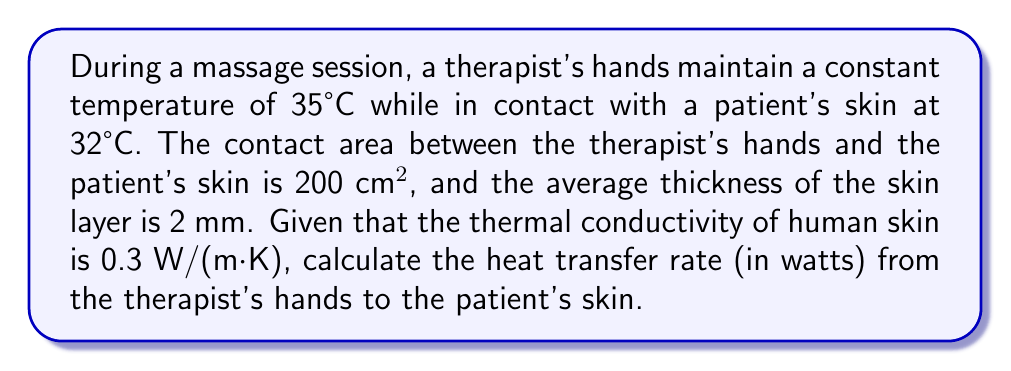Could you help me with this problem? To solve this problem, we'll use Fourier's law of heat conduction:

$$ Q = -kA\frac{dT}{dx} $$

Where:
$Q$ = heat transfer rate (W)
$k$ = thermal conductivity of the material (W/(m·K))
$A$ = cross-sectional area (m²)
$\frac{dT}{dx}$ = temperature gradient (K/m)

Given:
- $k = 0.3$ W/(m·K)
- $A = 200$ cm² = $0.02$ m²
- $T_{therapist} = 35°C$
- $T_{patient} = 32°C$
- $\Delta x = 2$ mm = $0.002$ m

Step 1: Calculate the temperature gradient
$\frac{dT}{dx} = \frac{T_{patient} - T_{therapist}}{\Delta x} = \frac{32 - 35}{0.002} = -1500$ K/m

Step 2: Apply Fourier's law of heat conduction
$$ Q = -kA\frac{dT}{dx} $$
$$ Q = -(0.3)(0.02)(-1500) $$
$$ Q = 9 \text{ W} $$

The negative sign in Fourier's law indicates that heat flows from higher to lower temperature. Since we're interested in the magnitude of heat transfer, we take the absolute value.
Answer: 9 W 